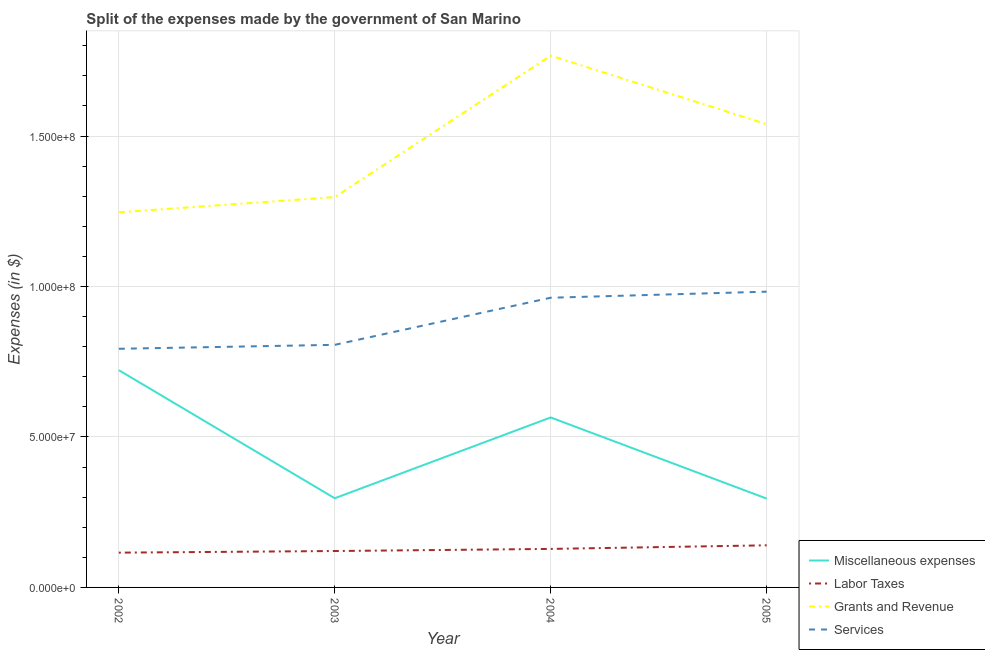Is the number of lines equal to the number of legend labels?
Your answer should be compact. Yes. What is the amount spent on miscellaneous expenses in 2005?
Make the answer very short. 2.95e+07. Across all years, what is the maximum amount spent on services?
Make the answer very short. 9.83e+07. Across all years, what is the minimum amount spent on miscellaneous expenses?
Keep it short and to the point. 2.95e+07. In which year was the amount spent on labor taxes minimum?
Give a very brief answer. 2002. What is the total amount spent on miscellaneous expenses in the graph?
Provide a short and direct response. 1.88e+08. What is the difference between the amount spent on services in 2003 and that in 2004?
Your answer should be very brief. -1.57e+07. What is the difference between the amount spent on services in 2002 and the amount spent on grants and revenue in 2003?
Make the answer very short. -5.04e+07. What is the average amount spent on labor taxes per year?
Your answer should be very brief. 1.26e+07. In the year 2002, what is the difference between the amount spent on labor taxes and amount spent on miscellaneous expenses?
Keep it short and to the point. -6.06e+07. What is the ratio of the amount spent on grants and revenue in 2002 to that in 2003?
Make the answer very short. 0.96. Is the difference between the amount spent on services in 2004 and 2005 greater than the difference between the amount spent on labor taxes in 2004 and 2005?
Offer a terse response. No. What is the difference between the highest and the second highest amount spent on services?
Give a very brief answer. 2.02e+06. What is the difference between the highest and the lowest amount spent on grants and revenue?
Your answer should be compact. 5.21e+07. In how many years, is the amount spent on labor taxes greater than the average amount spent on labor taxes taken over all years?
Provide a succinct answer. 2. Is the amount spent on services strictly greater than the amount spent on miscellaneous expenses over the years?
Keep it short and to the point. Yes. Is the amount spent on labor taxes strictly less than the amount spent on grants and revenue over the years?
Offer a terse response. Yes. What is the difference between two consecutive major ticks on the Y-axis?
Offer a very short reply. 5.00e+07. Does the graph contain grids?
Give a very brief answer. Yes. How are the legend labels stacked?
Give a very brief answer. Vertical. What is the title of the graph?
Give a very brief answer. Split of the expenses made by the government of San Marino. Does "UNDP" appear as one of the legend labels in the graph?
Your answer should be compact. No. What is the label or title of the Y-axis?
Provide a succinct answer. Expenses (in $). What is the Expenses (in $) of Miscellaneous expenses in 2002?
Make the answer very short. 7.22e+07. What is the Expenses (in $) of Labor Taxes in 2002?
Give a very brief answer. 1.16e+07. What is the Expenses (in $) of Grants and Revenue in 2002?
Make the answer very short. 1.25e+08. What is the Expenses (in $) of Services in 2002?
Provide a succinct answer. 7.93e+07. What is the Expenses (in $) of Miscellaneous expenses in 2003?
Offer a terse response. 2.96e+07. What is the Expenses (in $) of Labor Taxes in 2003?
Keep it short and to the point. 1.21e+07. What is the Expenses (in $) of Grants and Revenue in 2003?
Offer a terse response. 1.30e+08. What is the Expenses (in $) of Services in 2003?
Provide a succinct answer. 8.06e+07. What is the Expenses (in $) in Miscellaneous expenses in 2004?
Give a very brief answer. 5.65e+07. What is the Expenses (in $) of Labor Taxes in 2004?
Provide a succinct answer. 1.28e+07. What is the Expenses (in $) of Grants and Revenue in 2004?
Make the answer very short. 1.77e+08. What is the Expenses (in $) of Services in 2004?
Your answer should be compact. 9.63e+07. What is the Expenses (in $) in Miscellaneous expenses in 2005?
Your answer should be very brief. 2.95e+07. What is the Expenses (in $) of Labor Taxes in 2005?
Your answer should be compact. 1.40e+07. What is the Expenses (in $) in Grants and Revenue in 2005?
Provide a succinct answer. 1.54e+08. What is the Expenses (in $) in Services in 2005?
Give a very brief answer. 9.83e+07. Across all years, what is the maximum Expenses (in $) of Miscellaneous expenses?
Make the answer very short. 7.22e+07. Across all years, what is the maximum Expenses (in $) of Labor Taxes?
Offer a terse response. 1.40e+07. Across all years, what is the maximum Expenses (in $) of Grants and Revenue?
Your response must be concise. 1.77e+08. Across all years, what is the maximum Expenses (in $) of Services?
Make the answer very short. 9.83e+07. Across all years, what is the minimum Expenses (in $) of Miscellaneous expenses?
Your response must be concise. 2.95e+07. Across all years, what is the minimum Expenses (in $) of Labor Taxes?
Your response must be concise. 1.16e+07. Across all years, what is the minimum Expenses (in $) in Grants and Revenue?
Make the answer very short. 1.25e+08. Across all years, what is the minimum Expenses (in $) of Services?
Ensure brevity in your answer.  7.93e+07. What is the total Expenses (in $) in Miscellaneous expenses in the graph?
Offer a very short reply. 1.88e+08. What is the total Expenses (in $) of Labor Taxes in the graph?
Provide a succinct answer. 5.05e+07. What is the total Expenses (in $) of Grants and Revenue in the graph?
Offer a very short reply. 5.85e+08. What is the total Expenses (in $) in Services in the graph?
Give a very brief answer. 3.55e+08. What is the difference between the Expenses (in $) of Miscellaneous expenses in 2002 and that in 2003?
Give a very brief answer. 4.26e+07. What is the difference between the Expenses (in $) of Labor Taxes in 2002 and that in 2003?
Your answer should be compact. -5.42e+05. What is the difference between the Expenses (in $) in Grants and Revenue in 2002 and that in 2003?
Offer a very short reply. -5.06e+06. What is the difference between the Expenses (in $) of Services in 2002 and that in 2003?
Provide a short and direct response. -1.31e+06. What is the difference between the Expenses (in $) of Miscellaneous expenses in 2002 and that in 2004?
Provide a short and direct response. 1.57e+07. What is the difference between the Expenses (in $) of Labor Taxes in 2002 and that in 2004?
Ensure brevity in your answer.  -1.24e+06. What is the difference between the Expenses (in $) in Grants and Revenue in 2002 and that in 2004?
Your answer should be compact. -5.21e+07. What is the difference between the Expenses (in $) of Services in 2002 and that in 2004?
Give a very brief answer. -1.70e+07. What is the difference between the Expenses (in $) in Miscellaneous expenses in 2002 and that in 2005?
Provide a short and direct response. 4.27e+07. What is the difference between the Expenses (in $) of Labor Taxes in 2002 and that in 2005?
Make the answer very short. -2.44e+06. What is the difference between the Expenses (in $) in Grants and Revenue in 2002 and that in 2005?
Keep it short and to the point. -2.93e+07. What is the difference between the Expenses (in $) in Services in 2002 and that in 2005?
Your answer should be very brief. -1.90e+07. What is the difference between the Expenses (in $) in Miscellaneous expenses in 2003 and that in 2004?
Your answer should be compact. -2.69e+07. What is the difference between the Expenses (in $) of Labor Taxes in 2003 and that in 2004?
Offer a terse response. -7.01e+05. What is the difference between the Expenses (in $) in Grants and Revenue in 2003 and that in 2004?
Provide a succinct answer. -4.70e+07. What is the difference between the Expenses (in $) in Services in 2003 and that in 2004?
Your response must be concise. -1.57e+07. What is the difference between the Expenses (in $) of Miscellaneous expenses in 2003 and that in 2005?
Offer a very short reply. 1.11e+05. What is the difference between the Expenses (in $) in Labor Taxes in 2003 and that in 2005?
Make the answer very short. -1.90e+06. What is the difference between the Expenses (in $) of Grants and Revenue in 2003 and that in 2005?
Your response must be concise. -2.42e+07. What is the difference between the Expenses (in $) of Services in 2003 and that in 2005?
Ensure brevity in your answer.  -1.77e+07. What is the difference between the Expenses (in $) of Miscellaneous expenses in 2004 and that in 2005?
Your answer should be very brief. 2.70e+07. What is the difference between the Expenses (in $) of Labor Taxes in 2004 and that in 2005?
Offer a terse response. -1.20e+06. What is the difference between the Expenses (in $) in Grants and Revenue in 2004 and that in 2005?
Your answer should be compact. 2.28e+07. What is the difference between the Expenses (in $) in Services in 2004 and that in 2005?
Give a very brief answer. -2.02e+06. What is the difference between the Expenses (in $) of Miscellaneous expenses in 2002 and the Expenses (in $) of Labor Taxes in 2003?
Make the answer very short. 6.01e+07. What is the difference between the Expenses (in $) of Miscellaneous expenses in 2002 and the Expenses (in $) of Grants and Revenue in 2003?
Your answer should be very brief. -5.75e+07. What is the difference between the Expenses (in $) in Miscellaneous expenses in 2002 and the Expenses (in $) in Services in 2003?
Your answer should be compact. -8.42e+06. What is the difference between the Expenses (in $) in Labor Taxes in 2002 and the Expenses (in $) in Grants and Revenue in 2003?
Your response must be concise. -1.18e+08. What is the difference between the Expenses (in $) in Labor Taxes in 2002 and the Expenses (in $) in Services in 2003?
Your answer should be compact. -6.91e+07. What is the difference between the Expenses (in $) in Grants and Revenue in 2002 and the Expenses (in $) in Services in 2003?
Keep it short and to the point. 4.40e+07. What is the difference between the Expenses (in $) in Miscellaneous expenses in 2002 and the Expenses (in $) in Labor Taxes in 2004?
Your answer should be very brief. 5.94e+07. What is the difference between the Expenses (in $) in Miscellaneous expenses in 2002 and the Expenses (in $) in Grants and Revenue in 2004?
Your response must be concise. -1.05e+08. What is the difference between the Expenses (in $) of Miscellaneous expenses in 2002 and the Expenses (in $) of Services in 2004?
Provide a short and direct response. -2.41e+07. What is the difference between the Expenses (in $) in Labor Taxes in 2002 and the Expenses (in $) in Grants and Revenue in 2004?
Your answer should be very brief. -1.65e+08. What is the difference between the Expenses (in $) in Labor Taxes in 2002 and the Expenses (in $) in Services in 2004?
Keep it short and to the point. -8.47e+07. What is the difference between the Expenses (in $) of Grants and Revenue in 2002 and the Expenses (in $) of Services in 2004?
Your answer should be very brief. 2.84e+07. What is the difference between the Expenses (in $) in Miscellaneous expenses in 2002 and the Expenses (in $) in Labor Taxes in 2005?
Offer a very short reply. 5.82e+07. What is the difference between the Expenses (in $) of Miscellaneous expenses in 2002 and the Expenses (in $) of Grants and Revenue in 2005?
Offer a terse response. -8.18e+07. What is the difference between the Expenses (in $) of Miscellaneous expenses in 2002 and the Expenses (in $) of Services in 2005?
Your answer should be compact. -2.61e+07. What is the difference between the Expenses (in $) of Labor Taxes in 2002 and the Expenses (in $) of Grants and Revenue in 2005?
Your answer should be compact. -1.42e+08. What is the difference between the Expenses (in $) in Labor Taxes in 2002 and the Expenses (in $) in Services in 2005?
Ensure brevity in your answer.  -8.67e+07. What is the difference between the Expenses (in $) of Grants and Revenue in 2002 and the Expenses (in $) of Services in 2005?
Give a very brief answer. 2.64e+07. What is the difference between the Expenses (in $) of Miscellaneous expenses in 2003 and the Expenses (in $) of Labor Taxes in 2004?
Ensure brevity in your answer.  1.68e+07. What is the difference between the Expenses (in $) in Miscellaneous expenses in 2003 and the Expenses (in $) in Grants and Revenue in 2004?
Your answer should be very brief. -1.47e+08. What is the difference between the Expenses (in $) of Miscellaneous expenses in 2003 and the Expenses (in $) of Services in 2004?
Provide a short and direct response. -6.66e+07. What is the difference between the Expenses (in $) in Labor Taxes in 2003 and the Expenses (in $) in Grants and Revenue in 2004?
Your answer should be very brief. -1.65e+08. What is the difference between the Expenses (in $) in Labor Taxes in 2003 and the Expenses (in $) in Services in 2004?
Your answer should be compact. -8.42e+07. What is the difference between the Expenses (in $) of Grants and Revenue in 2003 and the Expenses (in $) of Services in 2004?
Ensure brevity in your answer.  3.35e+07. What is the difference between the Expenses (in $) of Miscellaneous expenses in 2003 and the Expenses (in $) of Labor Taxes in 2005?
Give a very brief answer. 1.56e+07. What is the difference between the Expenses (in $) of Miscellaneous expenses in 2003 and the Expenses (in $) of Grants and Revenue in 2005?
Your answer should be very brief. -1.24e+08. What is the difference between the Expenses (in $) in Miscellaneous expenses in 2003 and the Expenses (in $) in Services in 2005?
Give a very brief answer. -6.87e+07. What is the difference between the Expenses (in $) of Labor Taxes in 2003 and the Expenses (in $) of Grants and Revenue in 2005?
Your answer should be compact. -1.42e+08. What is the difference between the Expenses (in $) in Labor Taxes in 2003 and the Expenses (in $) in Services in 2005?
Your answer should be compact. -8.62e+07. What is the difference between the Expenses (in $) in Grants and Revenue in 2003 and the Expenses (in $) in Services in 2005?
Make the answer very short. 3.14e+07. What is the difference between the Expenses (in $) of Miscellaneous expenses in 2004 and the Expenses (in $) of Labor Taxes in 2005?
Your answer should be very brief. 4.25e+07. What is the difference between the Expenses (in $) of Miscellaneous expenses in 2004 and the Expenses (in $) of Grants and Revenue in 2005?
Your answer should be very brief. -9.75e+07. What is the difference between the Expenses (in $) in Miscellaneous expenses in 2004 and the Expenses (in $) in Services in 2005?
Make the answer very short. -4.18e+07. What is the difference between the Expenses (in $) of Labor Taxes in 2004 and the Expenses (in $) of Grants and Revenue in 2005?
Provide a succinct answer. -1.41e+08. What is the difference between the Expenses (in $) in Labor Taxes in 2004 and the Expenses (in $) in Services in 2005?
Your answer should be very brief. -8.55e+07. What is the difference between the Expenses (in $) in Grants and Revenue in 2004 and the Expenses (in $) in Services in 2005?
Your answer should be very brief. 7.84e+07. What is the average Expenses (in $) in Miscellaneous expenses per year?
Give a very brief answer. 4.70e+07. What is the average Expenses (in $) in Labor Taxes per year?
Offer a terse response. 1.26e+07. What is the average Expenses (in $) in Grants and Revenue per year?
Your answer should be compact. 1.46e+08. What is the average Expenses (in $) of Services per year?
Your answer should be very brief. 8.86e+07. In the year 2002, what is the difference between the Expenses (in $) in Miscellaneous expenses and Expenses (in $) in Labor Taxes?
Offer a terse response. 6.06e+07. In the year 2002, what is the difference between the Expenses (in $) in Miscellaneous expenses and Expenses (in $) in Grants and Revenue?
Your response must be concise. -5.25e+07. In the year 2002, what is the difference between the Expenses (in $) in Miscellaneous expenses and Expenses (in $) in Services?
Offer a terse response. -7.11e+06. In the year 2002, what is the difference between the Expenses (in $) in Labor Taxes and Expenses (in $) in Grants and Revenue?
Give a very brief answer. -1.13e+08. In the year 2002, what is the difference between the Expenses (in $) of Labor Taxes and Expenses (in $) of Services?
Give a very brief answer. -6.78e+07. In the year 2002, what is the difference between the Expenses (in $) of Grants and Revenue and Expenses (in $) of Services?
Your response must be concise. 4.54e+07. In the year 2003, what is the difference between the Expenses (in $) in Miscellaneous expenses and Expenses (in $) in Labor Taxes?
Provide a succinct answer. 1.75e+07. In the year 2003, what is the difference between the Expenses (in $) in Miscellaneous expenses and Expenses (in $) in Grants and Revenue?
Your response must be concise. -1.00e+08. In the year 2003, what is the difference between the Expenses (in $) in Miscellaneous expenses and Expenses (in $) in Services?
Make the answer very short. -5.10e+07. In the year 2003, what is the difference between the Expenses (in $) of Labor Taxes and Expenses (in $) of Grants and Revenue?
Offer a terse response. -1.18e+08. In the year 2003, what is the difference between the Expenses (in $) of Labor Taxes and Expenses (in $) of Services?
Provide a short and direct response. -6.85e+07. In the year 2003, what is the difference between the Expenses (in $) of Grants and Revenue and Expenses (in $) of Services?
Provide a succinct answer. 4.91e+07. In the year 2004, what is the difference between the Expenses (in $) of Miscellaneous expenses and Expenses (in $) of Labor Taxes?
Make the answer very short. 4.37e+07. In the year 2004, what is the difference between the Expenses (in $) in Miscellaneous expenses and Expenses (in $) in Grants and Revenue?
Keep it short and to the point. -1.20e+08. In the year 2004, what is the difference between the Expenses (in $) in Miscellaneous expenses and Expenses (in $) in Services?
Provide a short and direct response. -3.98e+07. In the year 2004, what is the difference between the Expenses (in $) of Labor Taxes and Expenses (in $) of Grants and Revenue?
Provide a succinct answer. -1.64e+08. In the year 2004, what is the difference between the Expenses (in $) in Labor Taxes and Expenses (in $) in Services?
Offer a very short reply. -8.35e+07. In the year 2004, what is the difference between the Expenses (in $) in Grants and Revenue and Expenses (in $) in Services?
Your response must be concise. 8.04e+07. In the year 2005, what is the difference between the Expenses (in $) in Miscellaneous expenses and Expenses (in $) in Labor Taxes?
Provide a short and direct response. 1.55e+07. In the year 2005, what is the difference between the Expenses (in $) of Miscellaneous expenses and Expenses (in $) of Grants and Revenue?
Keep it short and to the point. -1.24e+08. In the year 2005, what is the difference between the Expenses (in $) of Miscellaneous expenses and Expenses (in $) of Services?
Give a very brief answer. -6.88e+07. In the year 2005, what is the difference between the Expenses (in $) of Labor Taxes and Expenses (in $) of Grants and Revenue?
Keep it short and to the point. -1.40e+08. In the year 2005, what is the difference between the Expenses (in $) in Labor Taxes and Expenses (in $) in Services?
Offer a very short reply. -8.43e+07. In the year 2005, what is the difference between the Expenses (in $) in Grants and Revenue and Expenses (in $) in Services?
Give a very brief answer. 5.57e+07. What is the ratio of the Expenses (in $) in Miscellaneous expenses in 2002 to that in 2003?
Your answer should be compact. 2.44. What is the ratio of the Expenses (in $) of Labor Taxes in 2002 to that in 2003?
Offer a very short reply. 0.96. What is the ratio of the Expenses (in $) of Services in 2002 to that in 2003?
Offer a terse response. 0.98. What is the ratio of the Expenses (in $) of Miscellaneous expenses in 2002 to that in 2004?
Your answer should be very brief. 1.28. What is the ratio of the Expenses (in $) of Labor Taxes in 2002 to that in 2004?
Provide a succinct answer. 0.9. What is the ratio of the Expenses (in $) of Grants and Revenue in 2002 to that in 2004?
Your answer should be compact. 0.71. What is the ratio of the Expenses (in $) in Services in 2002 to that in 2004?
Keep it short and to the point. 0.82. What is the ratio of the Expenses (in $) in Miscellaneous expenses in 2002 to that in 2005?
Your response must be concise. 2.45. What is the ratio of the Expenses (in $) of Labor Taxes in 2002 to that in 2005?
Ensure brevity in your answer.  0.83. What is the ratio of the Expenses (in $) in Grants and Revenue in 2002 to that in 2005?
Provide a succinct answer. 0.81. What is the ratio of the Expenses (in $) of Services in 2002 to that in 2005?
Give a very brief answer. 0.81. What is the ratio of the Expenses (in $) of Miscellaneous expenses in 2003 to that in 2004?
Your answer should be compact. 0.52. What is the ratio of the Expenses (in $) in Labor Taxes in 2003 to that in 2004?
Offer a terse response. 0.95. What is the ratio of the Expenses (in $) in Grants and Revenue in 2003 to that in 2004?
Keep it short and to the point. 0.73. What is the ratio of the Expenses (in $) in Services in 2003 to that in 2004?
Ensure brevity in your answer.  0.84. What is the ratio of the Expenses (in $) of Labor Taxes in 2003 to that in 2005?
Offer a very short reply. 0.86. What is the ratio of the Expenses (in $) of Grants and Revenue in 2003 to that in 2005?
Your response must be concise. 0.84. What is the ratio of the Expenses (in $) in Services in 2003 to that in 2005?
Offer a terse response. 0.82. What is the ratio of the Expenses (in $) in Miscellaneous expenses in 2004 to that in 2005?
Give a very brief answer. 1.91. What is the ratio of the Expenses (in $) in Labor Taxes in 2004 to that in 2005?
Keep it short and to the point. 0.91. What is the ratio of the Expenses (in $) of Grants and Revenue in 2004 to that in 2005?
Provide a succinct answer. 1.15. What is the ratio of the Expenses (in $) in Services in 2004 to that in 2005?
Your answer should be compact. 0.98. What is the difference between the highest and the second highest Expenses (in $) of Miscellaneous expenses?
Your answer should be compact. 1.57e+07. What is the difference between the highest and the second highest Expenses (in $) of Labor Taxes?
Provide a succinct answer. 1.20e+06. What is the difference between the highest and the second highest Expenses (in $) in Grants and Revenue?
Your answer should be compact. 2.28e+07. What is the difference between the highest and the second highest Expenses (in $) in Services?
Your answer should be compact. 2.02e+06. What is the difference between the highest and the lowest Expenses (in $) in Miscellaneous expenses?
Keep it short and to the point. 4.27e+07. What is the difference between the highest and the lowest Expenses (in $) of Labor Taxes?
Your answer should be very brief. 2.44e+06. What is the difference between the highest and the lowest Expenses (in $) in Grants and Revenue?
Give a very brief answer. 5.21e+07. What is the difference between the highest and the lowest Expenses (in $) of Services?
Make the answer very short. 1.90e+07. 